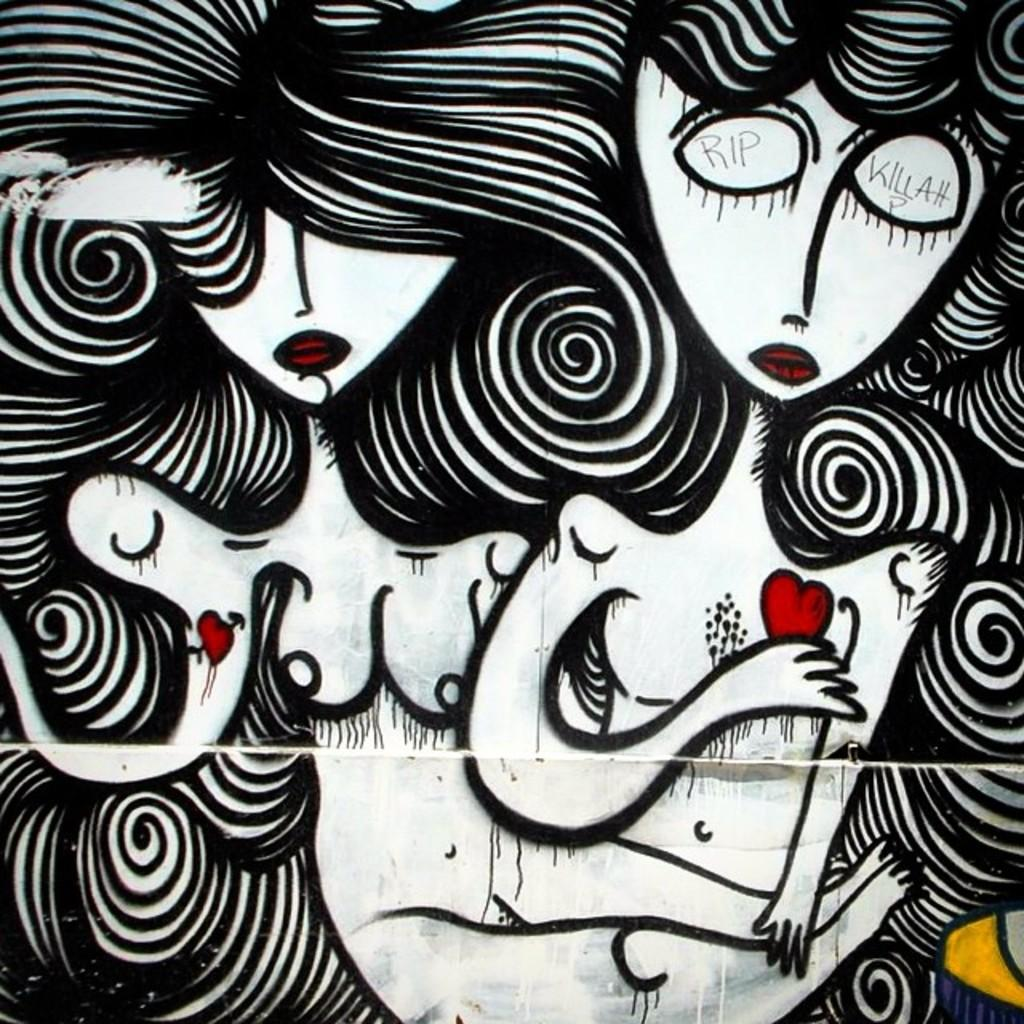What is depicted in the image? There is a drawing of two people in the image. Can you describe the people in the drawing? Unfortunately, the facts provided do not give any details about the appearance or actions of the people in the drawing. What is the context or setting of the drawing? Again, the facts provided do not give any information about the context or setting of the drawing. What type of company does the beggar in the image work for? There is no mention of a beggar or a company in the image, as the facts provided only state that there is a drawing of two people. 